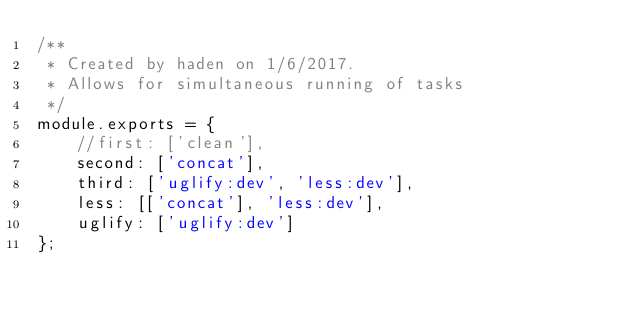<code> <loc_0><loc_0><loc_500><loc_500><_JavaScript_>/**
 * Created by haden on 1/6/2017.
 * Allows for simultaneous running of tasks
 */
module.exports = {
    //first: ['clean'],
    second: ['concat'],
    third: ['uglify:dev', 'less:dev'],
    less: [['concat'], 'less:dev'],
    uglify: ['uglify:dev']
};</code> 